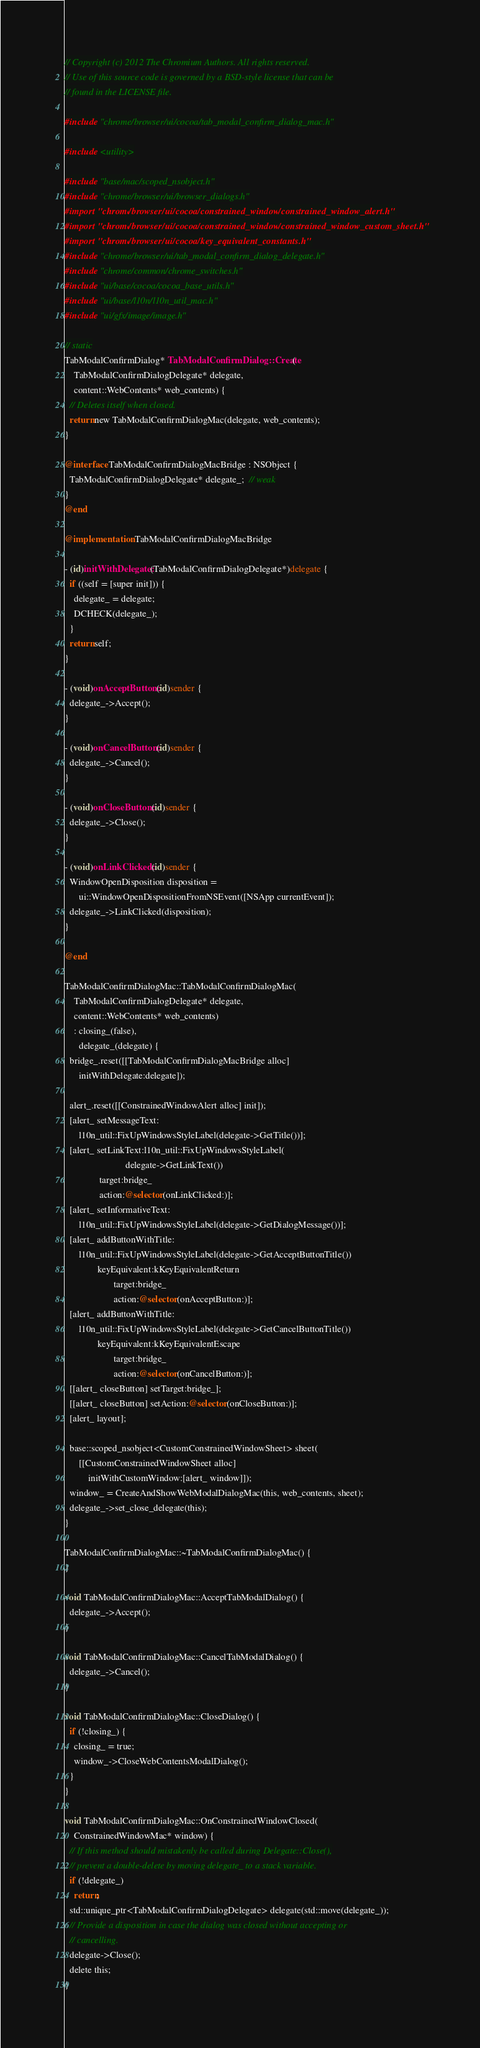Convert code to text. <code><loc_0><loc_0><loc_500><loc_500><_ObjectiveC_>// Copyright (c) 2012 The Chromium Authors. All rights reserved.
// Use of this source code is governed by a BSD-style license that can be
// found in the LICENSE file.

#include "chrome/browser/ui/cocoa/tab_modal_confirm_dialog_mac.h"

#include <utility>

#include "base/mac/scoped_nsobject.h"
#include "chrome/browser/ui/browser_dialogs.h"
#import "chrome/browser/ui/cocoa/constrained_window/constrained_window_alert.h"
#import "chrome/browser/ui/cocoa/constrained_window/constrained_window_custom_sheet.h"
#import "chrome/browser/ui/cocoa/key_equivalent_constants.h"
#include "chrome/browser/ui/tab_modal_confirm_dialog_delegate.h"
#include "chrome/common/chrome_switches.h"
#include "ui/base/cocoa/cocoa_base_utils.h"
#include "ui/base/l10n/l10n_util_mac.h"
#include "ui/gfx/image/image.h"

// static
TabModalConfirmDialog* TabModalConfirmDialog::Create(
    TabModalConfirmDialogDelegate* delegate,
    content::WebContents* web_contents) {
  // Deletes itself when closed.
  return new TabModalConfirmDialogMac(delegate, web_contents);
}

@interface TabModalConfirmDialogMacBridge : NSObject {
  TabModalConfirmDialogDelegate* delegate_;  // weak
}
@end

@implementation TabModalConfirmDialogMacBridge

- (id)initWithDelegate:(TabModalConfirmDialogDelegate*)delegate {
  if ((self = [super init])) {
    delegate_ = delegate;
    DCHECK(delegate_);
  }
  return self;
}

- (void)onAcceptButton:(id)sender {
  delegate_->Accept();
}

- (void)onCancelButton:(id)sender {
  delegate_->Cancel();
}

- (void)onCloseButton:(id)sender {
  delegate_->Close();
}

- (void)onLinkClicked:(id)sender {
  WindowOpenDisposition disposition =
      ui::WindowOpenDispositionFromNSEvent([NSApp currentEvent]);
  delegate_->LinkClicked(disposition);
}

@end

TabModalConfirmDialogMac::TabModalConfirmDialogMac(
    TabModalConfirmDialogDelegate* delegate,
    content::WebContents* web_contents)
    : closing_(false),
      delegate_(delegate) {
  bridge_.reset([[TabModalConfirmDialogMacBridge alloc]
      initWithDelegate:delegate]);

  alert_.reset([[ConstrainedWindowAlert alloc] init]);
  [alert_ setMessageText:
      l10n_util::FixUpWindowsStyleLabel(delegate->GetTitle())];
  [alert_ setLinkText:l10n_util::FixUpWindowsStyleLabel(
                          delegate->GetLinkText())
               target:bridge_
               action:@selector(onLinkClicked:)];
  [alert_ setInformativeText:
      l10n_util::FixUpWindowsStyleLabel(delegate->GetDialogMessage())];
  [alert_ addButtonWithTitle:
      l10n_util::FixUpWindowsStyleLabel(delegate->GetAcceptButtonTitle())
              keyEquivalent:kKeyEquivalentReturn
                     target:bridge_
                     action:@selector(onAcceptButton:)];
  [alert_ addButtonWithTitle:
      l10n_util::FixUpWindowsStyleLabel(delegate->GetCancelButtonTitle())
              keyEquivalent:kKeyEquivalentEscape
                     target:bridge_
                     action:@selector(onCancelButton:)];
  [[alert_ closeButton] setTarget:bridge_];
  [[alert_ closeButton] setAction:@selector(onCloseButton:)];
  [alert_ layout];

  base::scoped_nsobject<CustomConstrainedWindowSheet> sheet(
      [[CustomConstrainedWindowSheet alloc]
          initWithCustomWindow:[alert_ window]]);
  window_ = CreateAndShowWebModalDialogMac(this, web_contents, sheet);
  delegate_->set_close_delegate(this);
}

TabModalConfirmDialogMac::~TabModalConfirmDialogMac() {
}

void TabModalConfirmDialogMac::AcceptTabModalDialog() {
  delegate_->Accept();
}

void TabModalConfirmDialogMac::CancelTabModalDialog() {
  delegate_->Cancel();
}

void TabModalConfirmDialogMac::CloseDialog() {
  if (!closing_) {
    closing_ = true;
    window_->CloseWebContentsModalDialog();
  }
}

void TabModalConfirmDialogMac::OnConstrainedWindowClosed(
    ConstrainedWindowMac* window) {
  // If this method should mistakenly be called during Delegate::Close(),
  // prevent a double-delete by moving delegate_ to a stack variable.
  if (!delegate_)
    return;
  std::unique_ptr<TabModalConfirmDialogDelegate> delegate(std::move(delegate_));
  // Provide a disposition in case the dialog was closed without accepting or
  // cancelling.
  delegate->Close();
  delete this;
}
</code> 